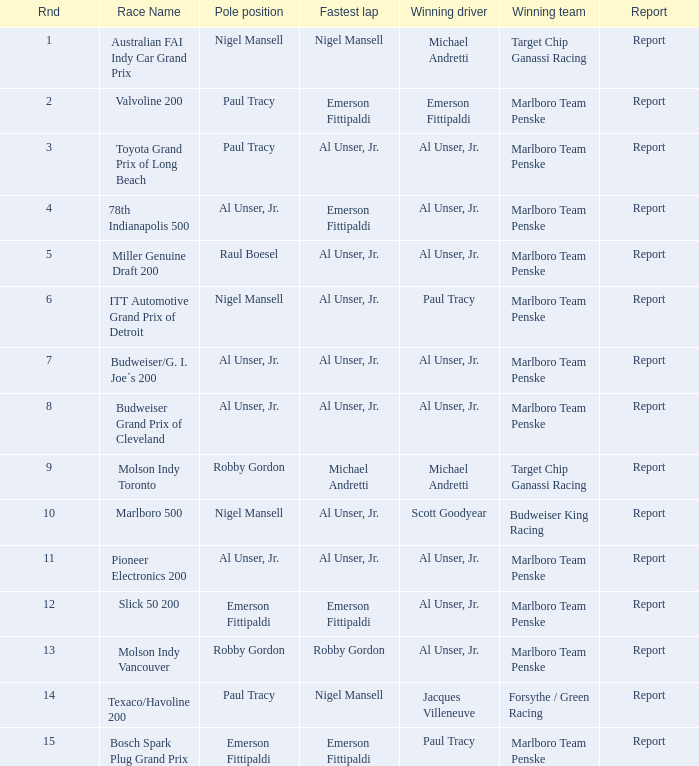Parse the table in full. {'header': ['Rnd', 'Race Name', 'Pole position', 'Fastest lap', 'Winning driver', 'Winning team', 'Report'], 'rows': [['1', 'Australian FAI Indy Car Grand Prix', 'Nigel Mansell', 'Nigel Mansell', 'Michael Andretti', 'Target Chip Ganassi Racing', 'Report'], ['2', 'Valvoline 200', 'Paul Tracy', 'Emerson Fittipaldi', 'Emerson Fittipaldi', 'Marlboro Team Penske', 'Report'], ['3', 'Toyota Grand Prix of Long Beach', 'Paul Tracy', 'Al Unser, Jr.', 'Al Unser, Jr.', 'Marlboro Team Penske', 'Report'], ['4', '78th Indianapolis 500', 'Al Unser, Jr.', 'Emerson Fittipaldi', 'Al Unser, Jr.', 'Marlboro Team Penske', 'Report'], ['5', 'Miller Genuine Draft 200', 'Raul Boesel', 'Al Unser, Jr.', 'Al Unser, Jr.', 'Marlboro Team Penske', 'Report'], ['6', 'ITT Automotive Grand Prix of Detroit', 'Nigel Mansell', 'Al Unser, Jr.', 'Paul Tracy', 'Marlboro Team Penske', 'Report'], ['7', 'Budweiser/G. I. Joe´s 200', 'Al Unser, Jr.', 'Al Unser, Jr.', 'Al Unser, Jr.', 'Marlboro Team Penske', 'Report'], ['8', 'Budweiser Grand Prix of Cleveland', 'Al Unser, Jr.', 'Al Unser, Jr.', 'Al Unser, Jr.', 'Marlboro Team Penske', 'Report'], ['9', 'Molson Indy Toronto', 'Robby Gordon', 'Michael Andretti', 'Michael Andretti', 'Target Chip Ganassi Racing', 'Report'], ['10', 'Marlboro 500', 'Nigel Mansell', 'Al Unser, Jr.', 'Scott Goodyear', 'Budweiser King Racing', 'Report'], ['11', 'Pioneer Electronics 200', 'Al Unser, Jr.', 'Al Unser, Jr.', 'Al Unser, Jr.', 'Marlboro Team Penske', 'Report'], ['12', 'Slick 50 200', 'Emerson Fittipaldi', 'Emerson Fittipaldi', 'Al Unser, Jr.', 'Marlboro Team Penske', 'Report'], ['13', 'Molson Indy Vancouver', 'Robby Gordon', 'Robby Gordon', 'Al Unser, Jr.', 'Marlboro Team Penske', 'Report'], ['14', 'Texaco/Havoline 200', 'Paul Tracy', 'Nigel Mansell', 'Jacques Villeneuve', 'Forsythe / Green Racing', 'Report'], ['15', 'Bosch Spark Plug Grand Prix', 'Emerson Fittipaldi', 'Emerson Fittipaldi', 'Paul Tracy', 'Marlboro Team Penske', 'Report']]} In the race with paul tracy as the winner and emerson fittipaldi in the pole position, who managed to achieve the fastest lap time? Emerson Fittipaldi. 